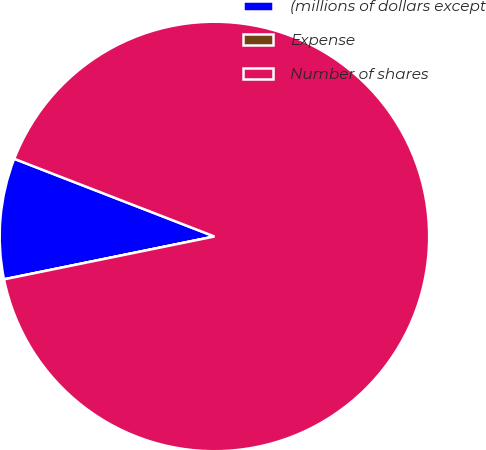<chart> <loc_0><loc_0><loc_500><loc_500><pie_chart><fcel>(millions of dollars except<fcel>Expense<fcel>Number of shares<nl><fcel>9.09%<fcel>0.0%<fcel>90.9%<nl></chart> 